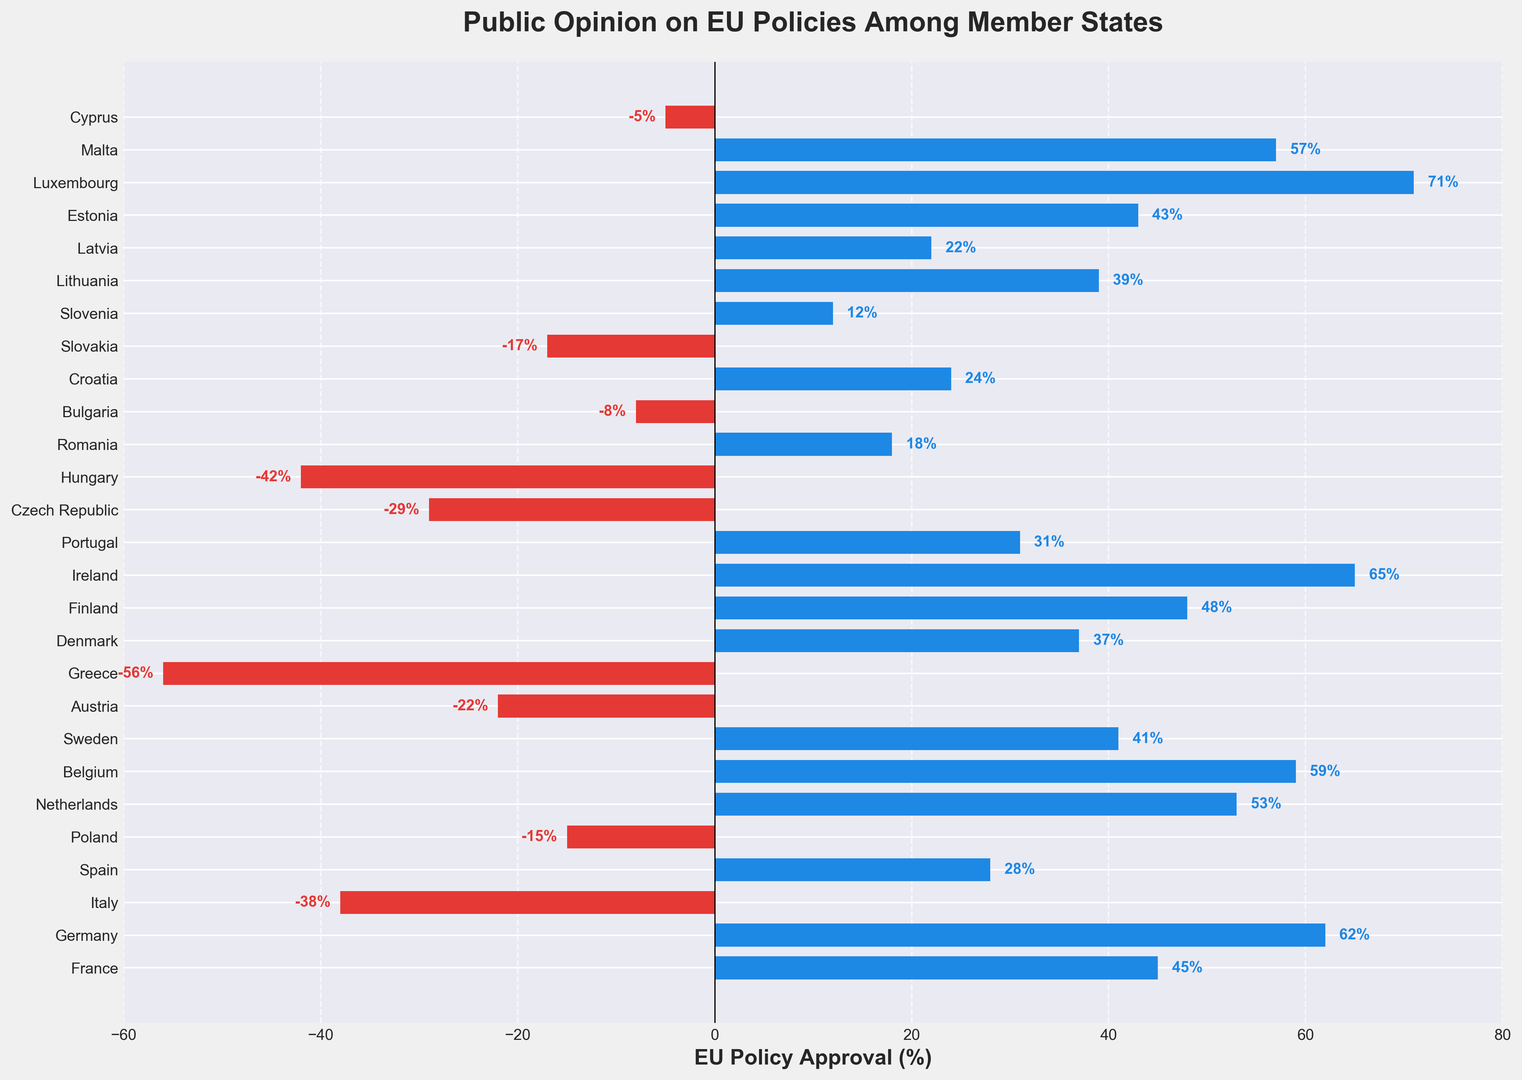Which country shows the highest approval percentage for EU policies? The country at the top of the list with the highest approval percentage is noted at the far right end of the chart with the highest bar. In this case, it is Luxembourg with 71%.
Answer: Luxembourg Which country exhibits the lowest approval percentage? The country with the lowest approval percentage will have the most negative value and the longest red bar extending to the left. Here, Greece has the lowest approval at -56%.
Answer: Greece What is the difference in approval percentage between Ireland and Finland? To find the difference, we subtract the approval percentage of Finland (48%) from Ireland (65%). 65 - 48 = 17.
Answer: 17 Which country has a positive approval percentage greater than 50%? The countries whose bars extend past the 50% mark on the positive side are Germany, Ireland, Luxembourg, Netherlands, and Malta.
Answer: Germany, Ireland, Luxembourg, Netherlands, Malta What is the average approval percentage among Germany, Belgium, and France? Sum the approval percentages of Germany (62%), Belgium (59%), and France (45%), then divide by three. (62 + 59 + 45) / 3 = 166 / 3 ≈ 55.33.
Answer: 55.33 How many countries have a negative approval percentage? Count the countries with negative values (red bars). These countries are Italy, Poland, Austria, Greece, Czech Republic, Hungary, Bulgaria, Slovakia, and Cyprus. There are 9 in total.
Answer: 9 Which countries have an approval percentage close to but not exceeding 50%? Identify the countries with approval percentages just below 50% but not exceeding it. These include Finland with 48%, France with 45%, and Estonia with 43%.
Answer: Finland, France, Estonia Among the countries with negative percentages, which one has the smallest value (closest to zero)? The country with the smallest negative value (closest to zero) is Cyprus with -5%.
Answer: Cyprus What's the sum of the approval percentages of Portugal, Poland, and Spain? Add the approval percentages of Portugal (31%), Poland (-15%), and Spain (28%). 31 + (-15) + 28 = 31 - 15 + 28 = 44.
Answer: 44 How does the EU policy approval in Sweden compare to that in Croatia? Sweden has an approval percentage of 41%, whereas Croatia has 24%. Since 41 is greater than 24, Sweden has a higher approval percentage.
Answer: Sweden has a higher approval 